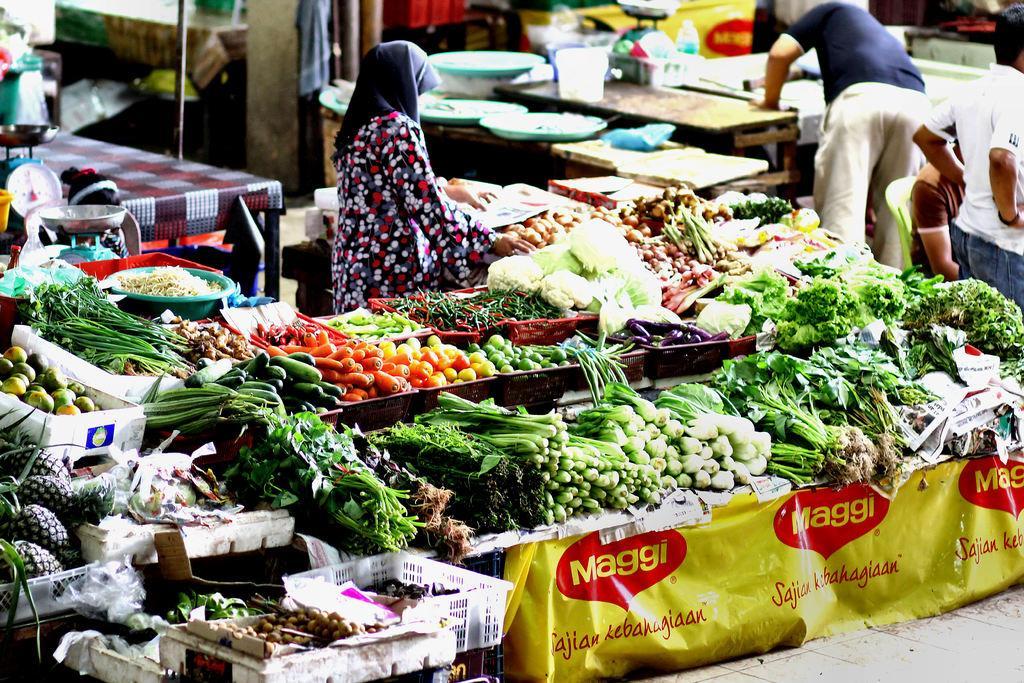How would you summarize this image in a sentence or two? In the picture we can see a vegetable shop filled with vegetables on the desk and some person standing near it and in the background also we can see some person standing and near the tables, and we can also see some poles and wall. 